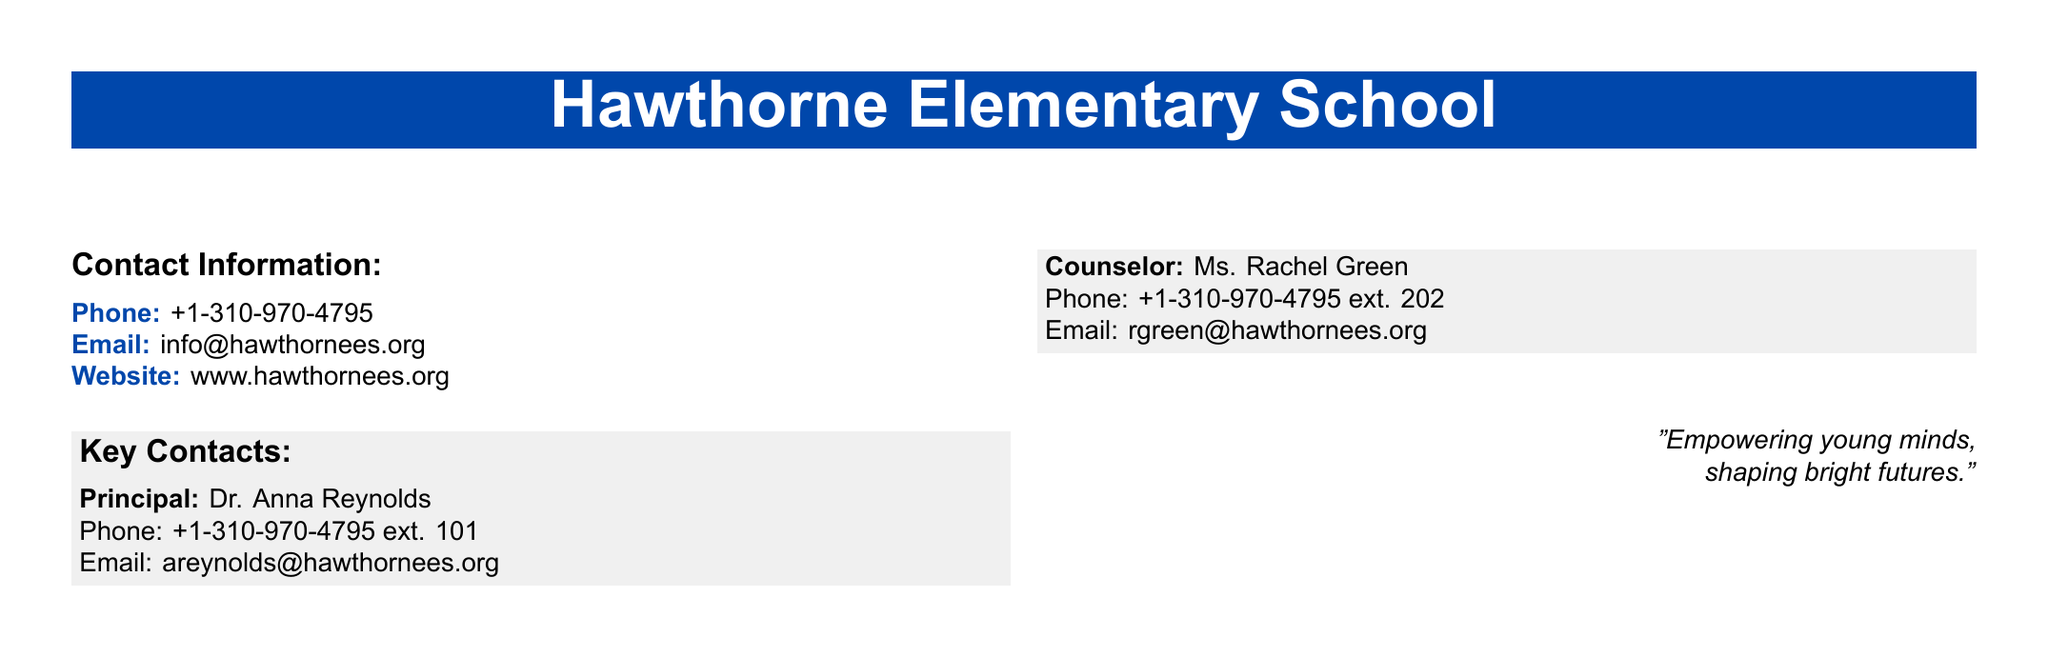What is the name of the school? The name of the school is provided in the document's header.
Answer: Hawthorne Elementary School What is the phone number of the school? The contact information for the school includes a phone number listed in the document.
Answer: +1-310-970-4795 Who is the principal? The key contact section lists the principal of the school.
Answer: Dr. Anna Reynolds What is the email address for the school? The document provides an email address associated with the school.
Answer: info@hawthornees.org What is the extension for the counselor? The counselor's contact information includes an extension number in the document.
Answer: 202 What are the two key contacts listed? The document specifies two key contacts for the school and their titles.
Answer: Principal, Counselor What is the website for Hawthorne Elementary School? The document contains a URL for the school's website mentioned in the contact information.
Answer: www.hawthornees.org What is the motto displayed on the document? The motto is a quote included in the document's design, representing the school's philosophy.
Answer: "Empowering young minds, shaping bright futures." 